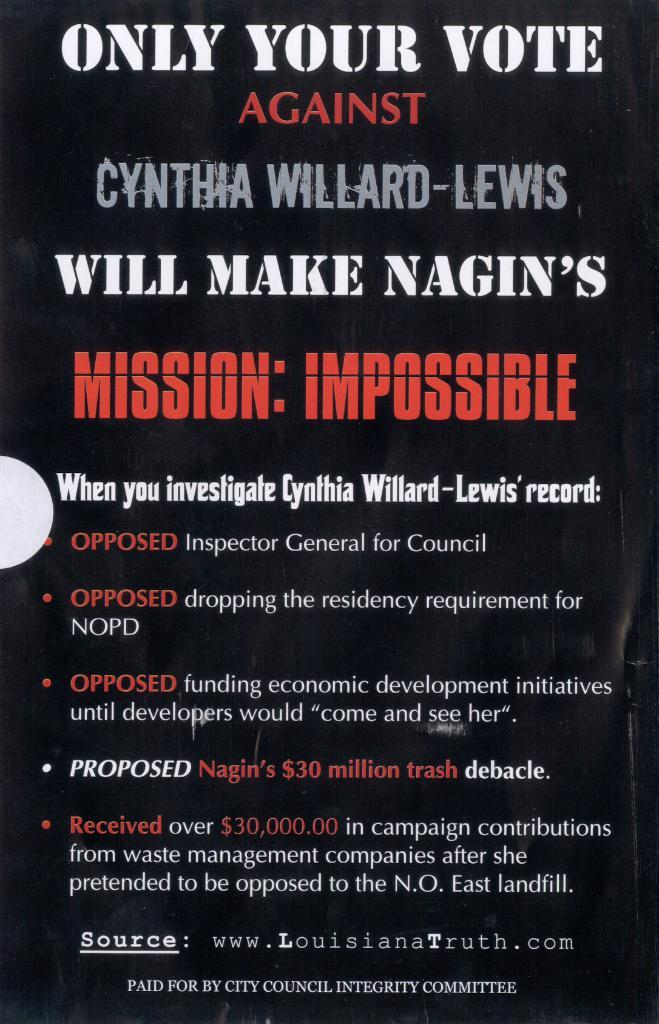<image>
Render a clear and concise summary of the photo. A sign by Louisiana Truth about Cynthia Willard-Lewis. 